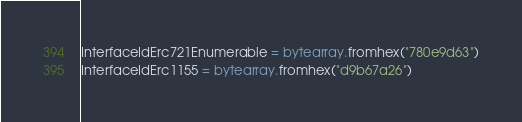Convert code to text. <code><loc_0><loc_0><loc_500><loc_500><_Python_>InterfaceIdErc721Enumerable = bytearray.fromhex("780e9d63")
InterfaceIdErc1155 = bytearray.fromhex("d9b67a26")
</code> 